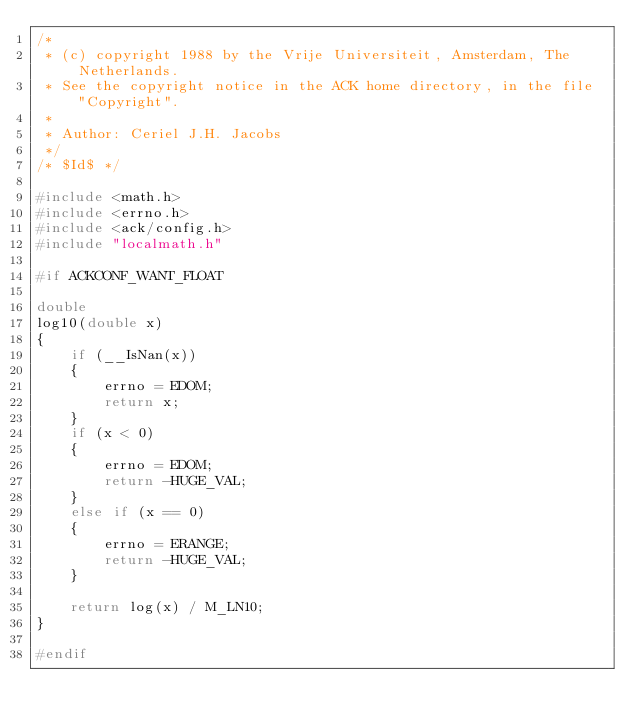<code> <loc_0><loc_0><loc_500><loc_500><_C_>/*
 * (c) copyright 1988 by the Vrije Universiteit, Amsterdam, The Netherlands.
 * See the copyright notice in the ACK home directory, in the file "Copyright".
 *
 * Author: Ceriel J.H. Jacobs
 */
/* $Id$ */

#include <math.h>
#include <errno.h>
#include <ack/config.h>
#include "localmath.h"

#if ACKCONF_WANT_FLOAT

double
log10(double x)
{
	if (__IsNan(x))
	{
		errno = EDOM;
		return x;
	}
	if (x < 0)
	{
		errno = EDOM;
		return -HUGE_VAL;
	}
	else if (x == 0)
	{
		errno = ERANGE;
		return -HUGE_VAL;
	}

	return log(x) / M_LN10;
}

#endif

</code> 